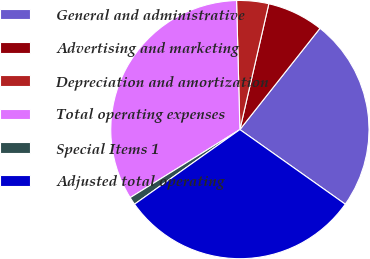Convert chart to OTSL. <chart><loc_0><loc_0><loc_500><loc_500><pie_chart><fcel>General and administrative<fcel>Advertising and marketing<fcel>Depreciation and amortization<fcel>Total operating expenses<fcel>Special Items 1<fcel>Adjusted total operating<nl><fcel>24.16%<fcel>7.05%<fcel>4.01%<fcel>33.43%<fcel>0.97%<fcel>30.39%<nl></chart> 